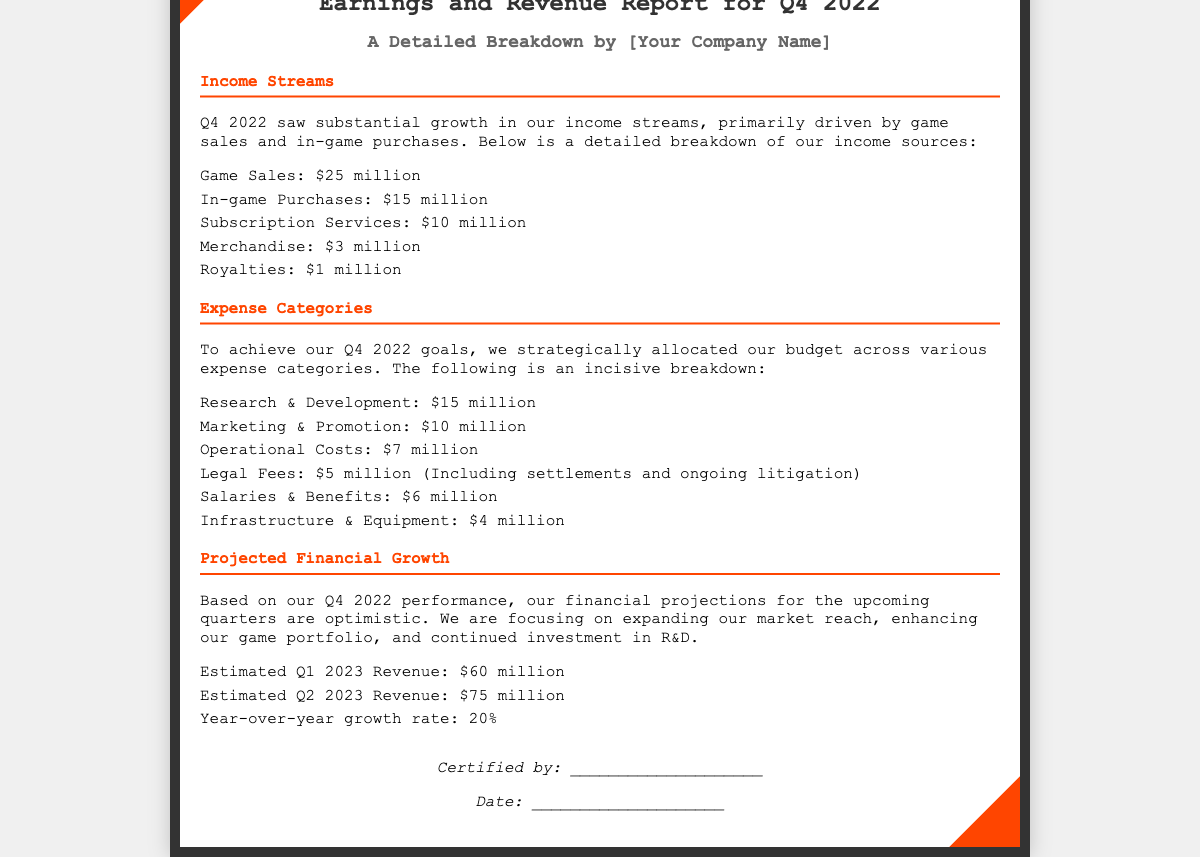What was the total income from game sales in Q4 2022? The total income from game sales can be found directly in the income streams section of the document, which states it's $25 million.
Answer: $25 million How much did the company allocate for legal fees? The amount allocated for legal fees is listed under the expense categories section, which shows it's $5 million.
Answer: $5 million What is the total estimated revenue for Q1 2023? The estimated revenue for Q1 2023 is provided in the projected financial growth section, indicating it is $60 million.
Answer: $60 million What is the year-over-year growth rate projected? The document states the year-over-year growth rate in the projected financial growth section, which is 20%.
Answer: 20% How much did in-game purchases contribute to total revenue in Q4 2022? The contribution from in-game purchases is specified in the income streams section, showing it's $15 million.
Answer: $15 million What are the two main income sources? The two main income sources can be found in the income streams section, which details game sales and in-game purchases.
Answer: Game Sales and In-game Purchases What was the total amount spent on marketing and promotion? The total spent on marketing and promotion is specified in the expense categories section, stated as $10 million.
Answer: $10 million Which section provides projections for future revenues? The section providing projections is titled "Projected Financial Growth."
Answer: Projected Financial Growth How much is expected from subscriptions in Q4 2022? The expected amount from subscriptions in Q4 2022 is listed in the income streams section as $10 million.
Answer: $10 million 